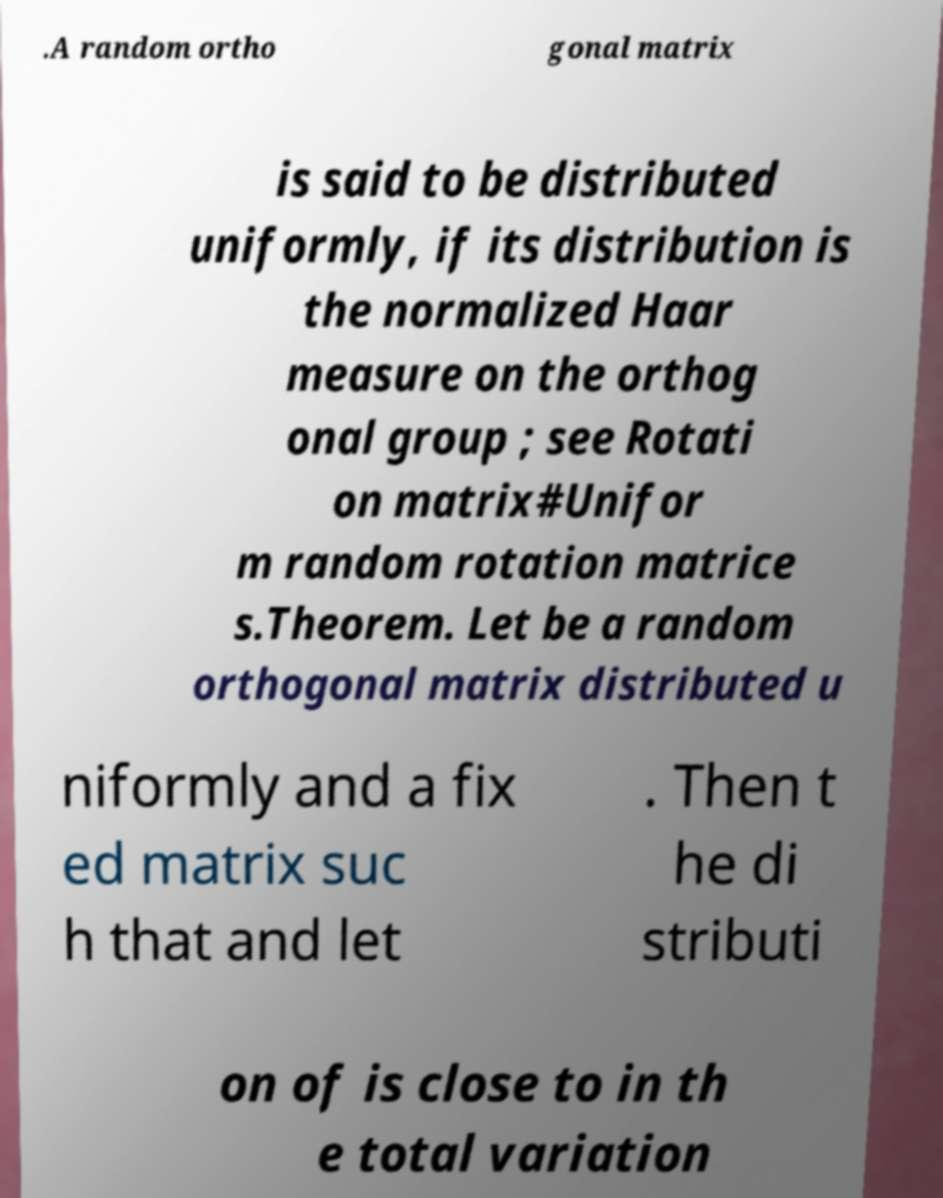There's text embedded in this image that I need extracted. Can you transcribe it verbatim? .A random ortho gonal matrix is said to be distributed uniformly, if its distribution is the normalized Haar measure on the orthog onal group ; see Rotati on matrix#Unifor m random rotation matrice s.Theorem. Let be a random orthogonal matrix distributed u niformly and a fix ed matrix suc h that and let . Then t he di stributi on of is close to in th e total variation 